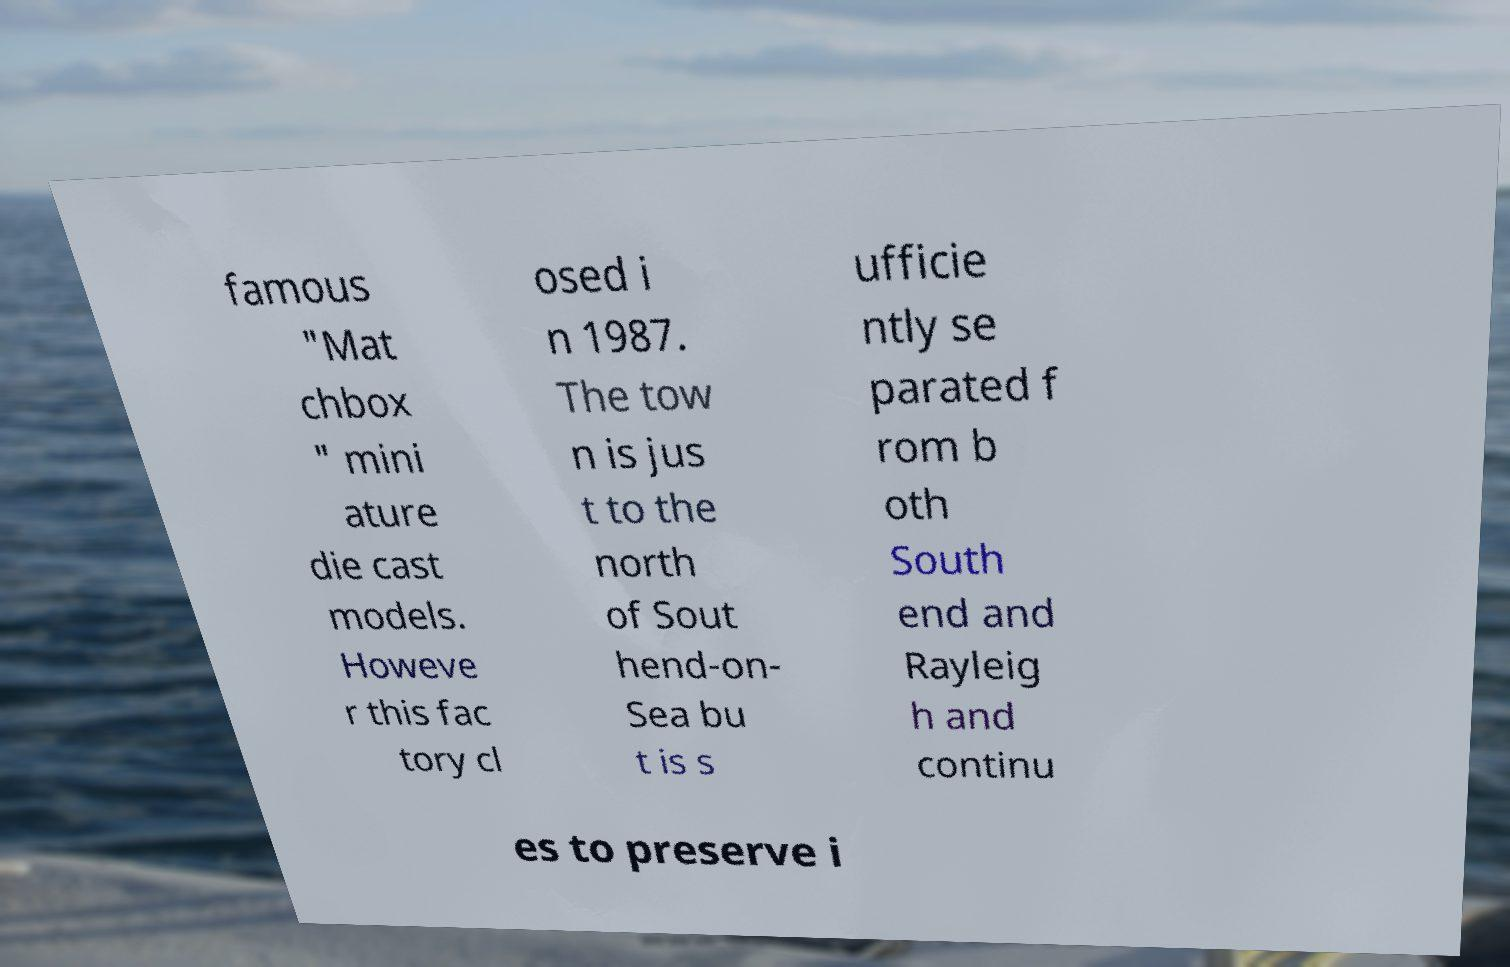I need the written content from this picture converted into text. Can you do that? famous "Mat chbox " mini ature die cast models. Howeve r this fac tory cl osed i n 1987. The tow n is jus t to the north of Sout hend-on- Sea bu t is s ufficie ntly se parated f rom b oth South end and Rayleig h and continu es to preserve i 